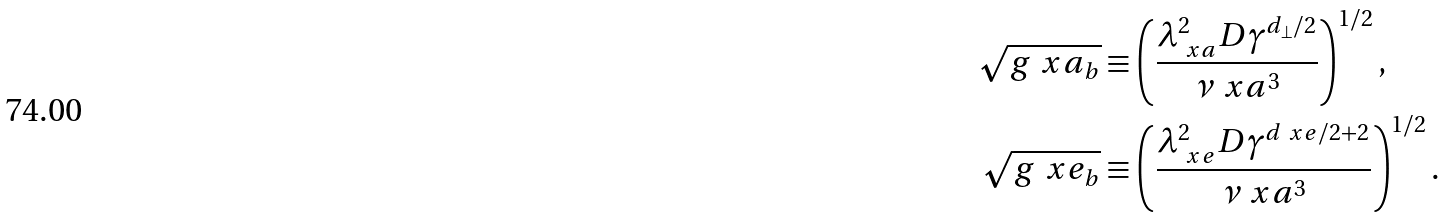<formula> <loc_0><loc_0><loc_500><loc_500>\sqrt { g ^ { \ } x a _ { b } } & \equiv \left ( \frac { \lambda _ { \ x a } ^ { 2 } D \gamma ^ { d _ { \perp } / 2 } } { \nu _ { \ } x a ^ { 3 } } \right ) ^ { 1 / 2 } , \\ \sqrt { g ^ { \ } x e _ { b } } & \equiv \left ( \frac { \lambda _ { \ x e } ^ { 2 } D \gamma ^ { d _ { \ } x e / 2 + 2 } } { \nu _ { \ } x a ^ { 3 } } \right ) ^ { 1 / 2 } .</formula> 